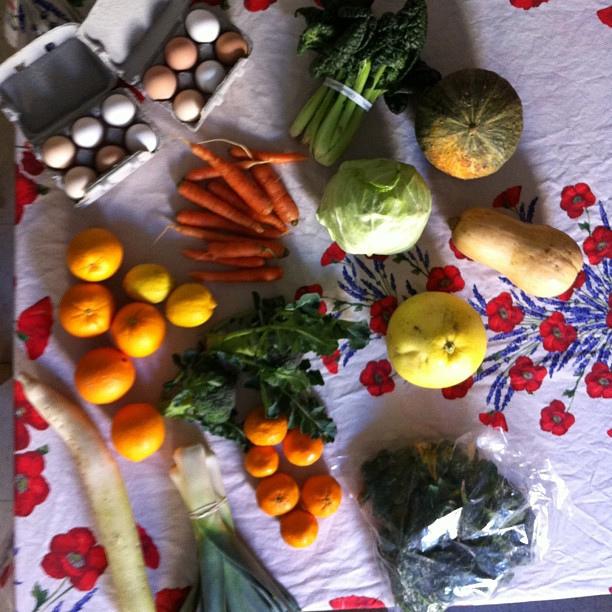Are these foods junky or healthy?
Concise answer only. Healthy. Which of these foods is the best source of protein?
Concise answer only. Eggs. What kind of fruit is yellow?
Write a very short answer. Lemon. 